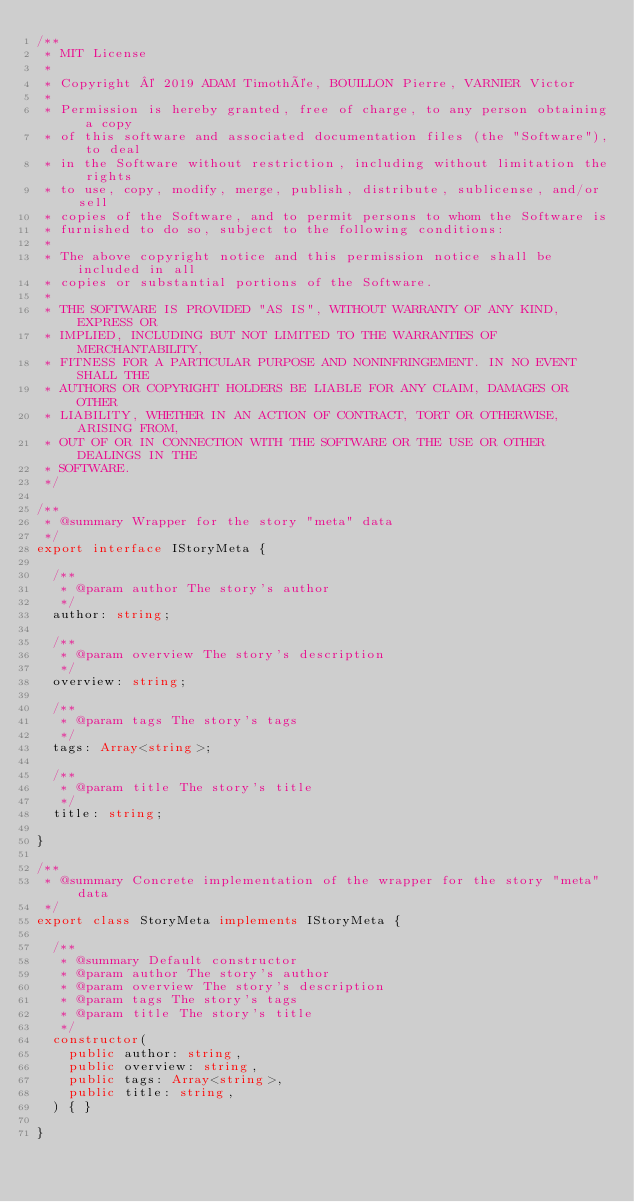<code> <loc_0><loc_0><loc_500><loc_500><_TypeScript_>/**
 * MIT License
 *
 * Copyright © 2019 ADAM Timothée, BOUILLON Pierre, VARNIER Victor
 *
 * Permission is hereby granted, free of charge, to any person obtaining a copy
 * of this software and associated documentation files (the "Software"), to deal
 * in the Software without restriction, including without limitation the rights
 * to use, copy, modify, merge, publish, distribute, sublicense, and/or sell
 * copies of the Software, and to permit persons to whom the Software is
 * furnished to do so, subject to the following conditions:
 *
 * The above copyright notice and this permission notice shall be included in all
 * copies or substantial portions of the Software.
 *
 * THE SOFTWARE IS PROVIDED "AS IS", WITHOUT WARRANTY OF ANY KIND, EXPRESS OR
 * IMPLIED, INCLUDING BUT NOT LIMITED TO THE WARRANTIES OF MERCHANTABILITY,
 * FITNESS FOR A PARTICULAR PURPOSE AND NONINFRINGEMENT. IN NO EVENT SHALL THE
 * AUTHORS OR COPYRIGHT HOLDERS BE LIABLE FOR ANY CLAIM, DAMAGES OR OTHER
 * LIABILITY, WHETHER IN AN ACTION OF CONTRACT, TORT OR OTHERWISE, ARISING FROM,
 * OUT OF OR IN CONNECTION WITH THE SOFTWARE OR THE USE OR OTHER DEALINGS IN THE
 * SOFTWARE.
 */

/**
 * @summary Wrapper for the story "meta" data
 */
export interface IStoryMeta {

  /**
   * @param author The story's author
   */
  author: string;

  /**
   * @param overview The story's description
   */
  overview: string;

  /**
   * @param tags The story's tags
   */
  tags: Array<string>;

  /**
   * @param title The story's title
   */
  title: string;

}

/**
 * @summary Concrete implementation of the wrapper for the story "meta" data
 */
export class StoryMeta implements IStoryMeta {

  /**
   * @summary Default constructor
   * @param author The story's author
   * @param overview The story's description
   * @param tags The story's tags
   * @param title The story's title
   */
  constructor(
    public author: string,
    public overview: string,
    public tags: Array<string>,
    public title: string,
  ) { }

}
</code> 